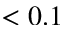Convert formula to latex. <formula><loc_0><loc_0><loc_500><loc_500>< 0 . 1</formula> 